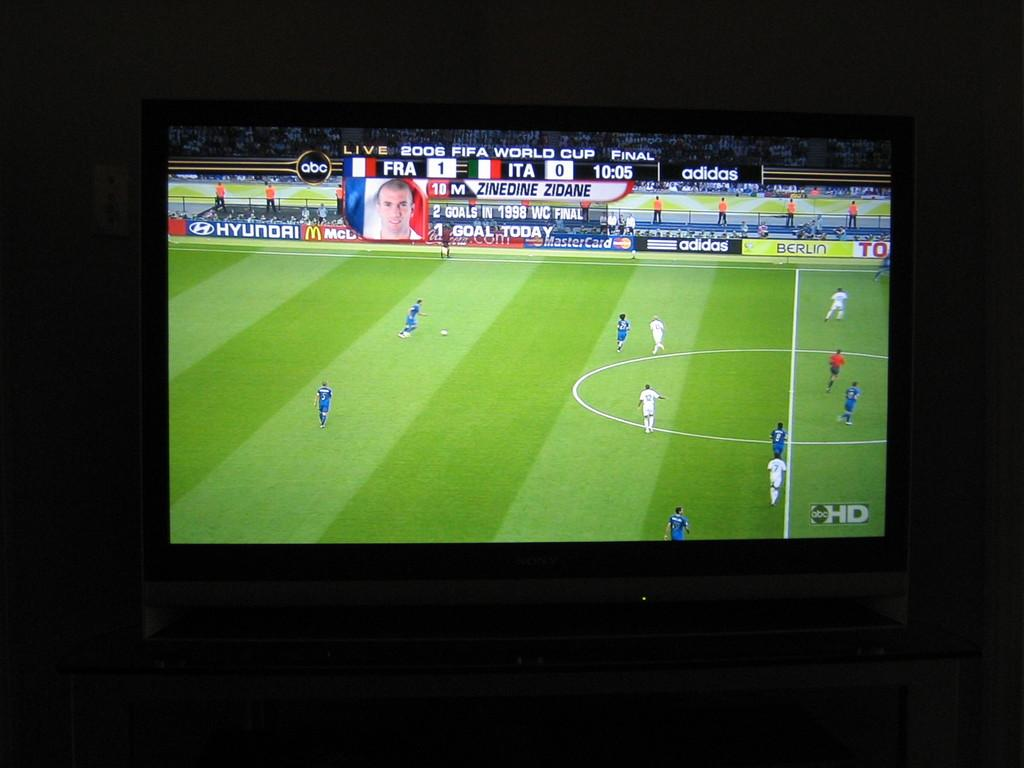<image>
Summarize the visual content of the image. A tv that has the 2006 FIFA World Cup Final between France and Italy with a score of 1-0 respectively. 